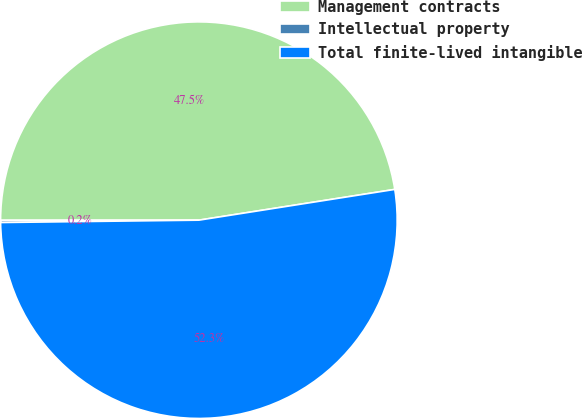Convert chart. <chart><loc_0><loc_0><loc_500><loc_500><pie_chart><fcel>Management contracts<fcel>Intellectual property<fcel>Total finite-lived intangible<nl><fcel>47.53%<fcel>0.18%<fcel>52.29%<nl></chart> 